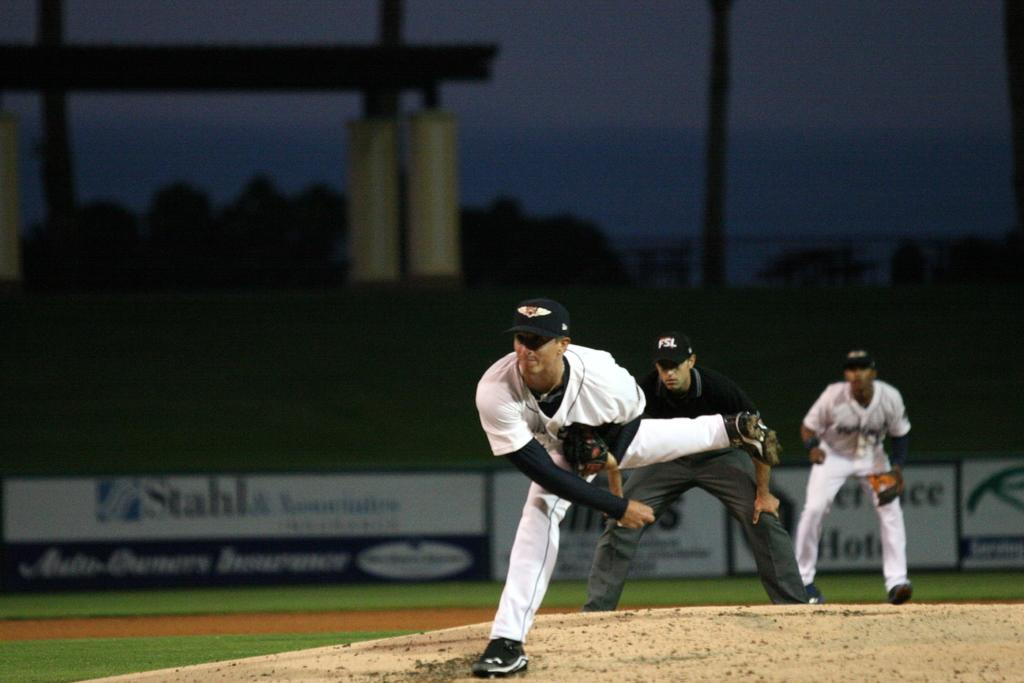<image>
Give a short and clear explanation of the subsequent image. Players in white jerseys on a field sponsored by Stahls 